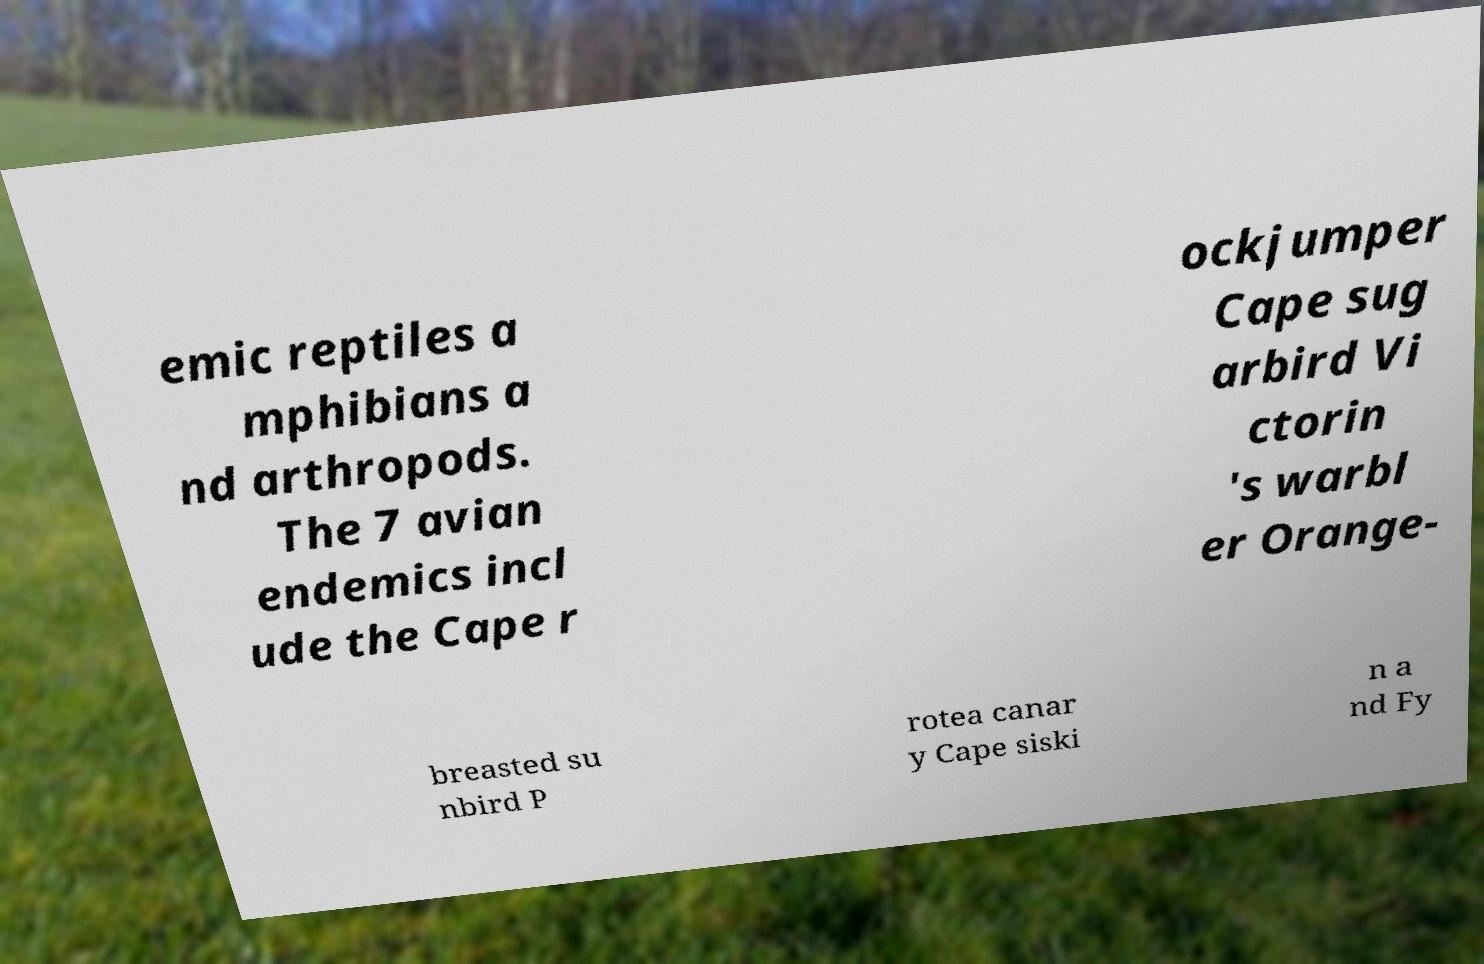Please read and relay the text visible in this image. What does it say? emic reptiles a mphibians a nd arthropods. The 7 avian endemics incl ude the Cape r ockjumper Cape sug arbird Vi ctorin 's warbl er Orange- breasted su nbird P rotea canar y Cape siski n a nd Fy 